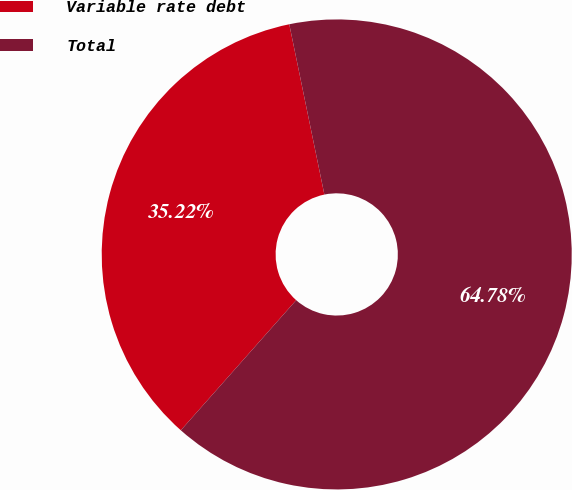Convert chart. <chart><loc_0><loc_0><loc_500><loc_500><pie_chart><fcel>Variable rate debt<fcel>Total<nl><fcel>35.22%<fcel>64.78%<nl></chart> 